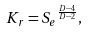Convert formula to latex. <formula><loc_0><loc_0><loc_500><loc_500>K _ { r } = { S _ { e } } ^ { \frac { D - 4 } { D - 2 } } ,</formula> 